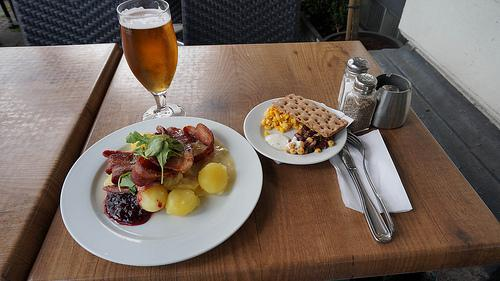Question: what is in the glass?
Choices:
A. Beer.
B. Water.
C. Soda.
D. Lemonade.
Answer with the letter. Answer: A Question: what is to the right of the small plate?
Choices:
A. Salt and pepper shaker.
B. A glass of water.
C. A jug of milk.
D. A bowl of cereal.
Answer with the letter. Answer: A Question: why is there silverware on the table?
Choices:
A. It's ready for dinner to be served.
B. To eat with.
C. It's waiting to be cleaned up.
D. It's there to eat my dinner.
Answer with the letter. Answer: B 